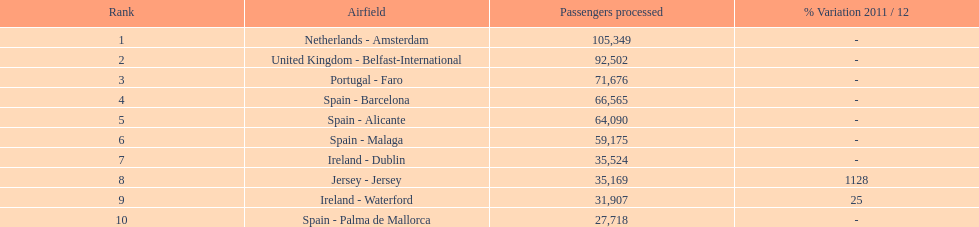What are the airports? Netherlands - Amsterdam, United Kingdom - Belfast-International, Portugal - Faro, Spain - Barcelona, Spain - Alicante, Spain - Malaga, Ireland - Dublin, Jersey - Jersey, Ireland - Waterford, Spain - Palma de Mallorca. Of these which has the least amount of passengers? Spain - Palma de Mallorca. 